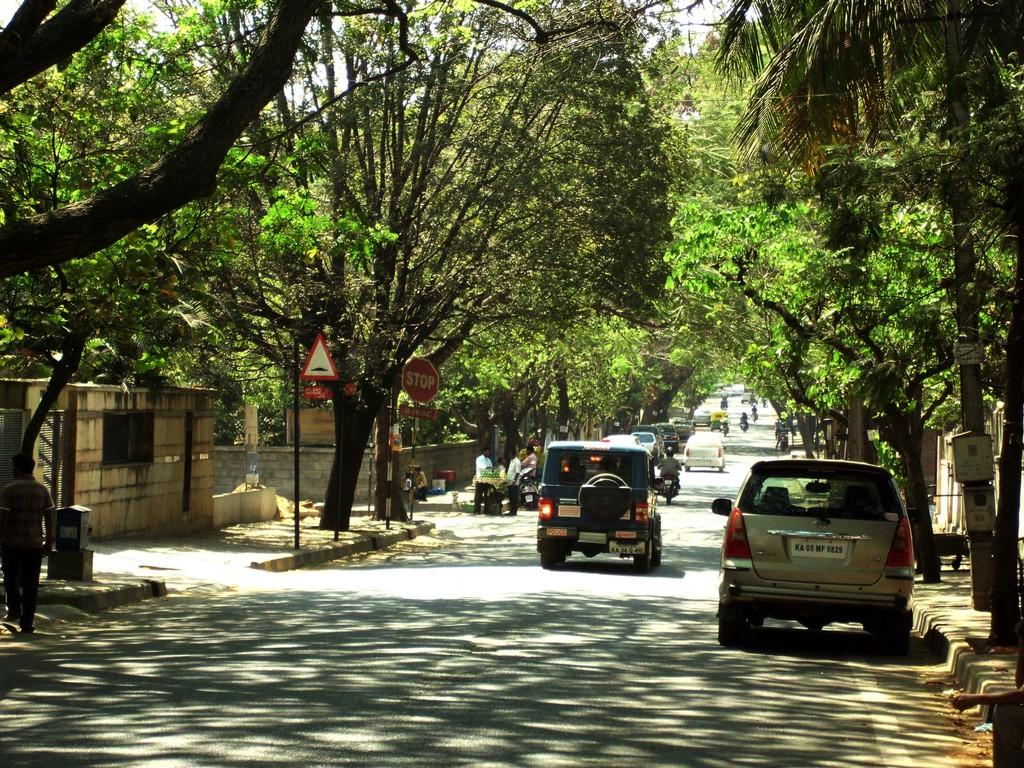What is the person in the image doing? There is a person walking in the image. What can be seen on the road in the image? There are vehicles on the road in the image. What is visible in the background of the image? There is a wall visible in the image. What type of vegetation is present in the image? There are trees in the image. Can you describe the people in the background of the image? There are people in the background of the image. What type of thunder can be heard in the image? There is no sound present in the image, so it is not possible to determine if there is any thunder. 